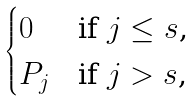Convert formula to latex. <formula><loc_0><loc_0><loc_500><loc_500>\begin{cases} 0 & \text {if $j \leq s$,} \\ P _ { j } & \text {if $j > s$,} \end{cases}</formula> 